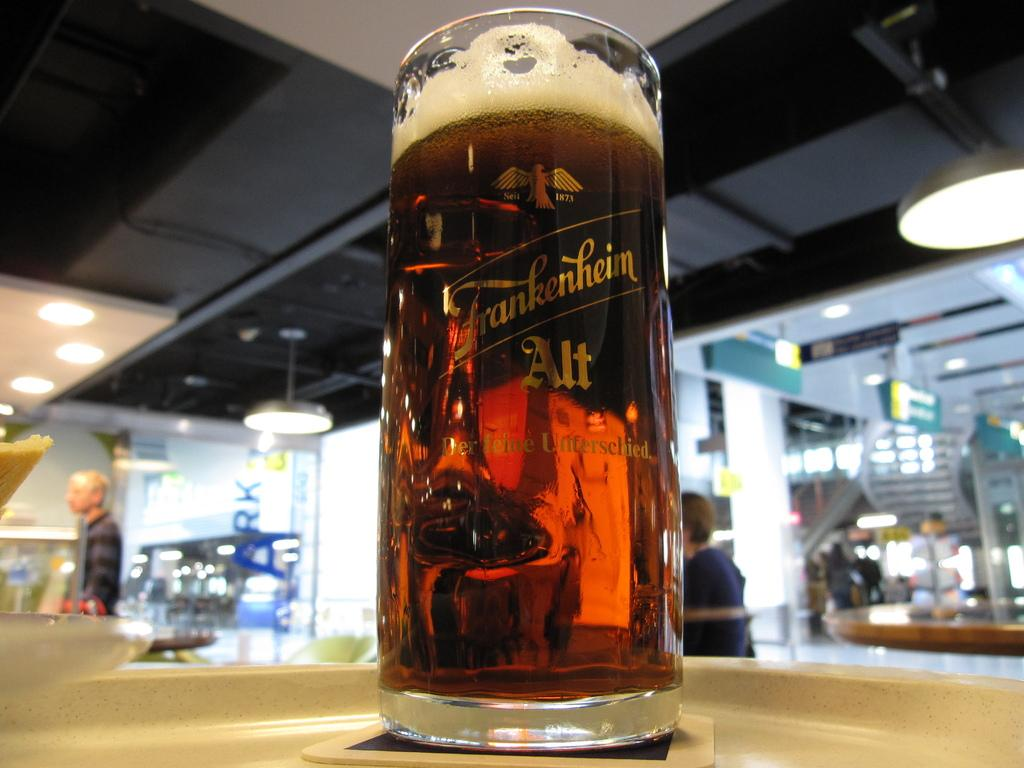<image>
Relay a brief, clear account of the picture shown. Beer Stein full of Frankenhein Alt sitting on a table 